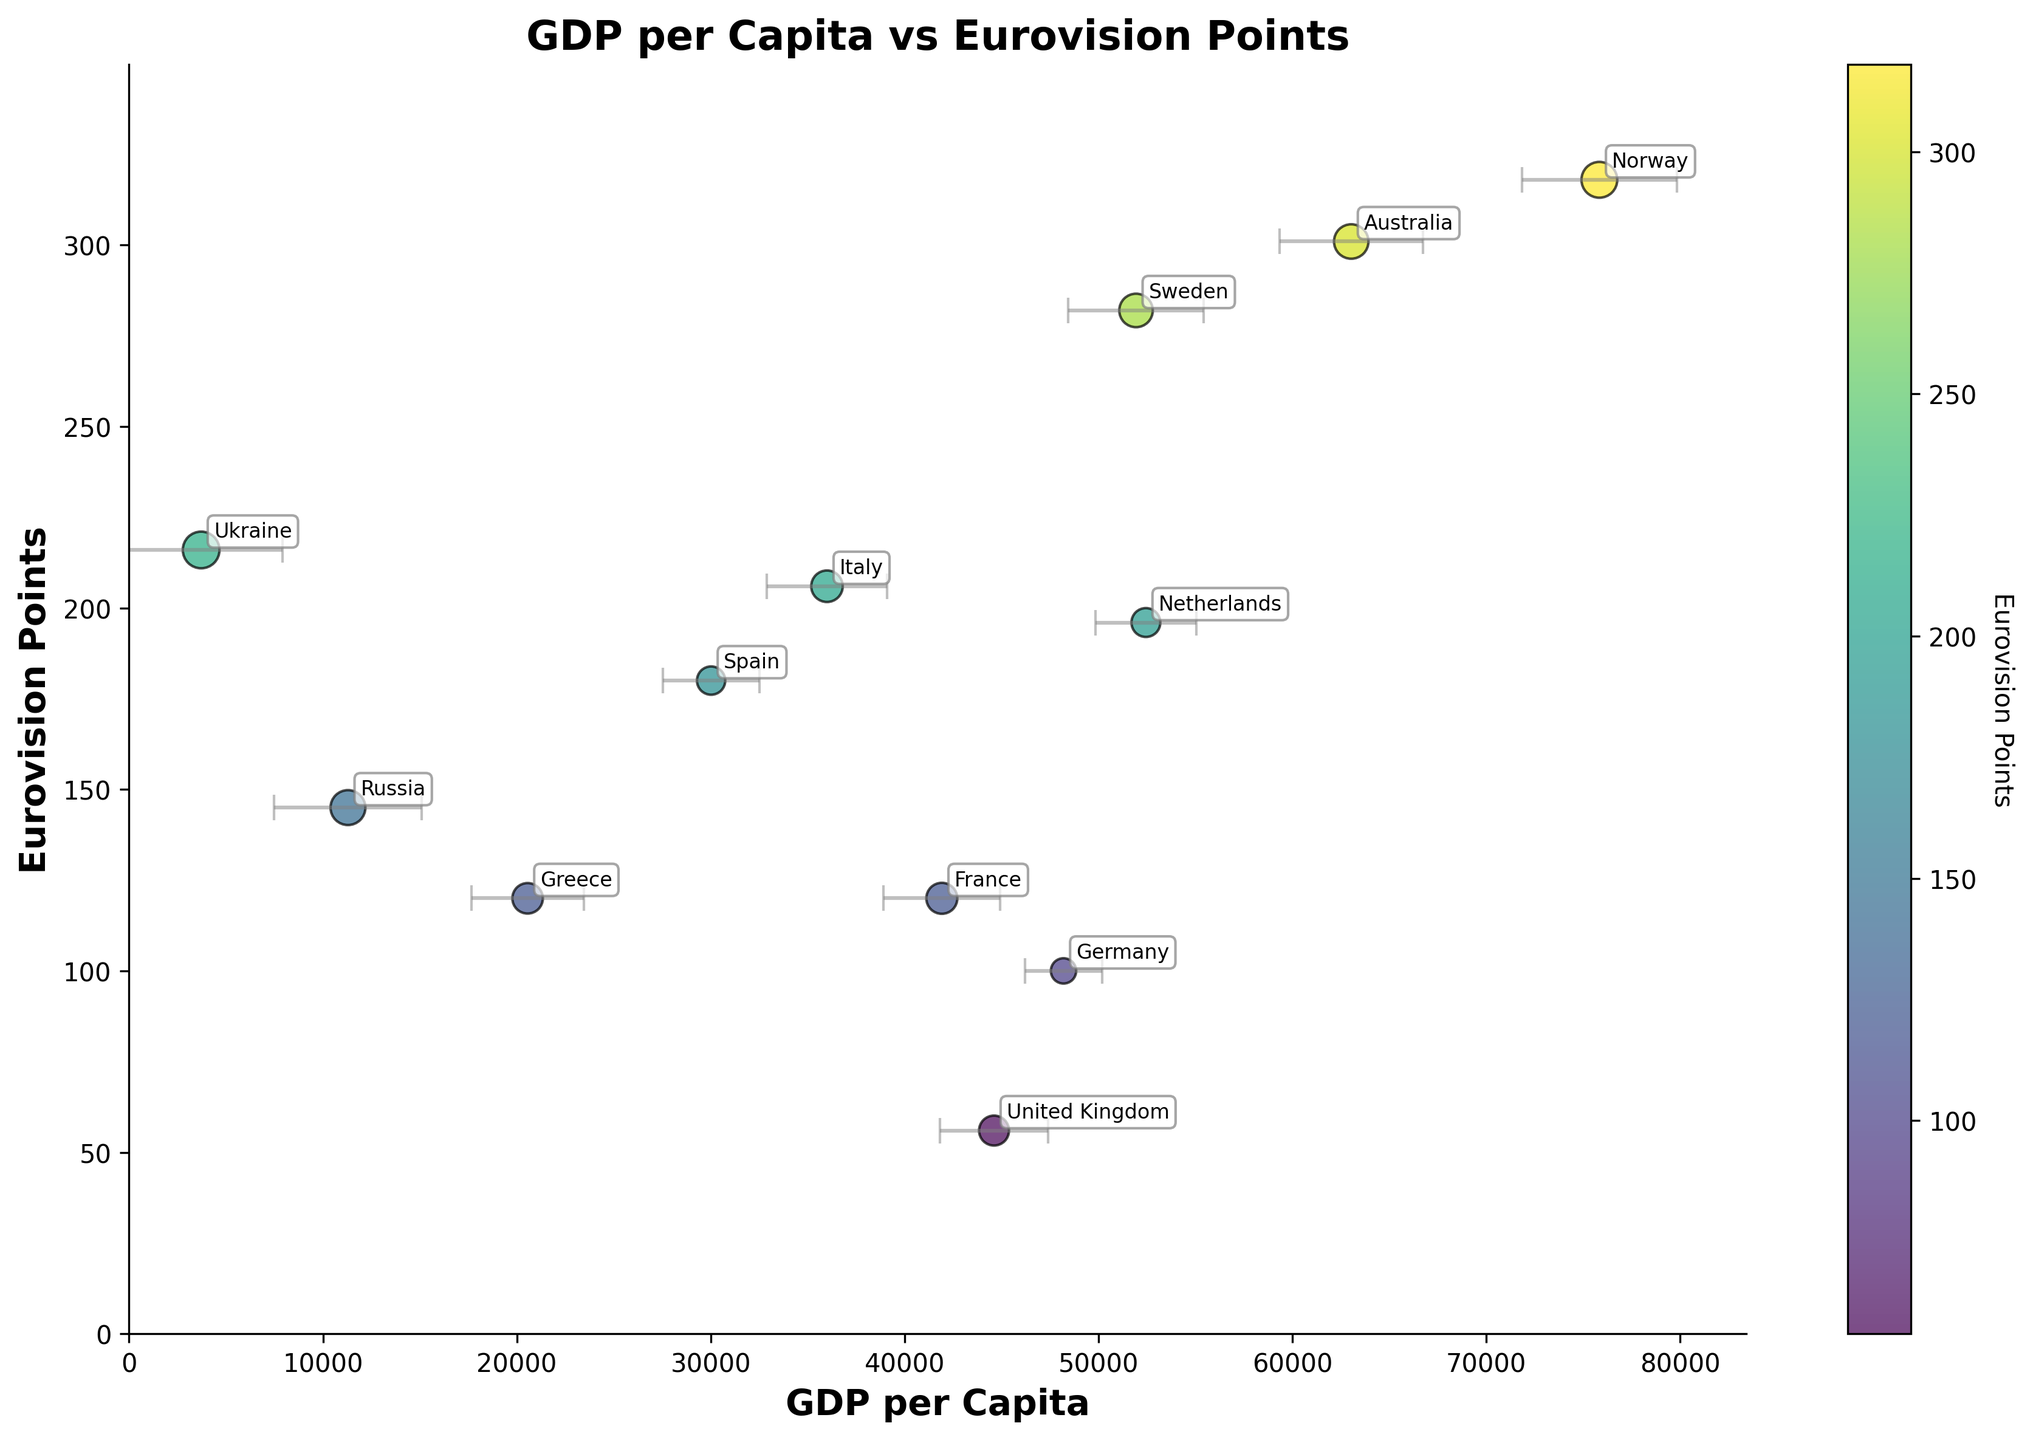Which country has the highest GDP per Capita? Norway is positioned farthest to the right on the x-axis, which represents GDP per Capita.
Answer: Norway What are the labels of the axes in the plot? The x-axis is labeled 'GDP per Capita' and the y-axis is labeled 'Eurovision Points'.
Answer: GDP per Capita, Eurovision Points Which two countries have the closest Eurovision Points? France and Greece are very close in terms of their position on the y-axis, which represents Eurovision Points.
Answer: France and Greece Which country has the largest error bar, and what does it indicate? Ukraine has the largest horizontal error bar, signifying the most significant economic trend uncertainty.
Answer: Ukraine How do Sweden and Italy compare in terms of Eurovision Points? When comparing the y-positions, Sweden has significantly more Eurovision Points than Italy.
Answer: Sweden has more What is the approximate GDP per Capita of Germany and its Eurovision Points? Germany is located at around 48,196 GDP per Capita on the x-axis and around 100 Eurovision Points on the y-axis.
Answer: 48,196, 100 Which country has the lowest GDP per Capita? Ukraine is positioned farthest to the left on the x-axis, which indicates the lowest GDP per Capita.
Answer: Ukraine Is there a noticeable trend between GDP per Capita and Eurovision Points received? The data points do not show a clear trend, as countries with varied GDP per Capita have both high and low Eurovision Points, indicating no apparent correlation.
Answer: No clear trend Name the country with the highest Eurovision Points and its GDP per Capita. Norway, positioned highest on the y-axis, has the most Eurovision Points. Its GDP per Capita is around 75,834.
Answer: Norway, 75,834 